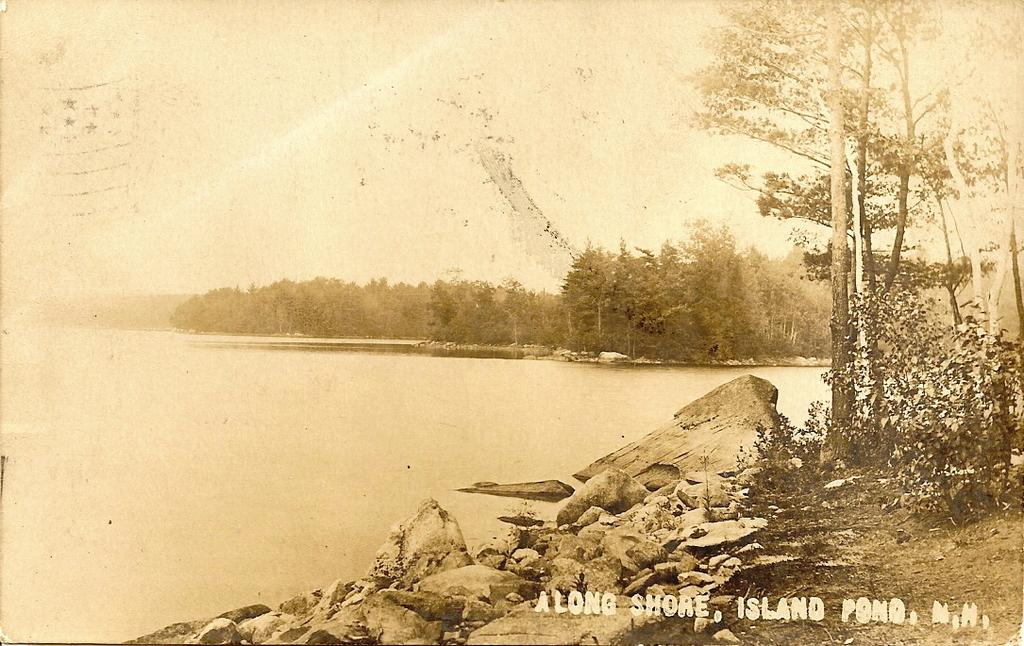What type of visual representation is shown in the image? The image is a poster. What natural elements are depicted on the poster? There are trees, water, and stones depicted on the poster. Are there any words or phrases on the poster? Yes, there is text on the poster. Is there a veil covering the trees in the image? No, there is no veil present in the image. How can you wash the stones depicted on the poster? The stones depicted on the poster are not real, so they cannot be washed. 